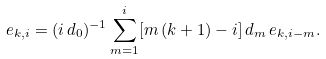<formula> <loc_0><loc_0><loc_500><loc_500>e _ { k , i } = ( i \, d _ { 0 } ) ^ { - 1 } \sum _ { m = 1 } ^ { i } [ m \, ( k + 1 ) - i ] \, d _ { m } \, e _ { k , i - m } .</formula> 